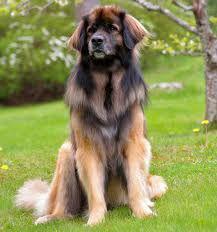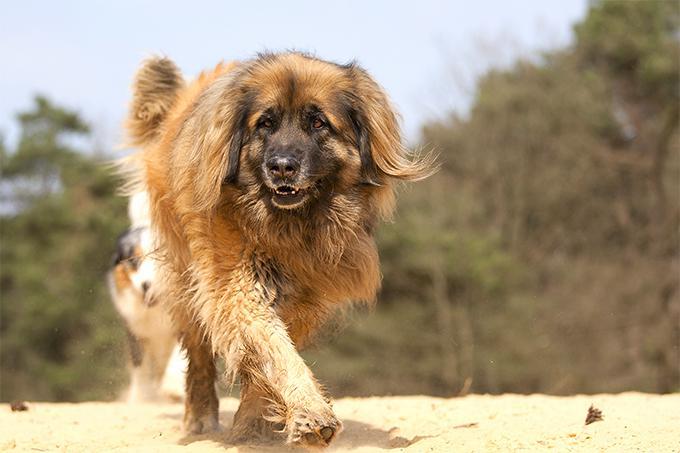The first image is the image on the left, the second image is the image on the right. For the images displayed, is the sentence "One image shows a puppy and the other shows an adult dog." factually correct? Answer yes or no. No. 